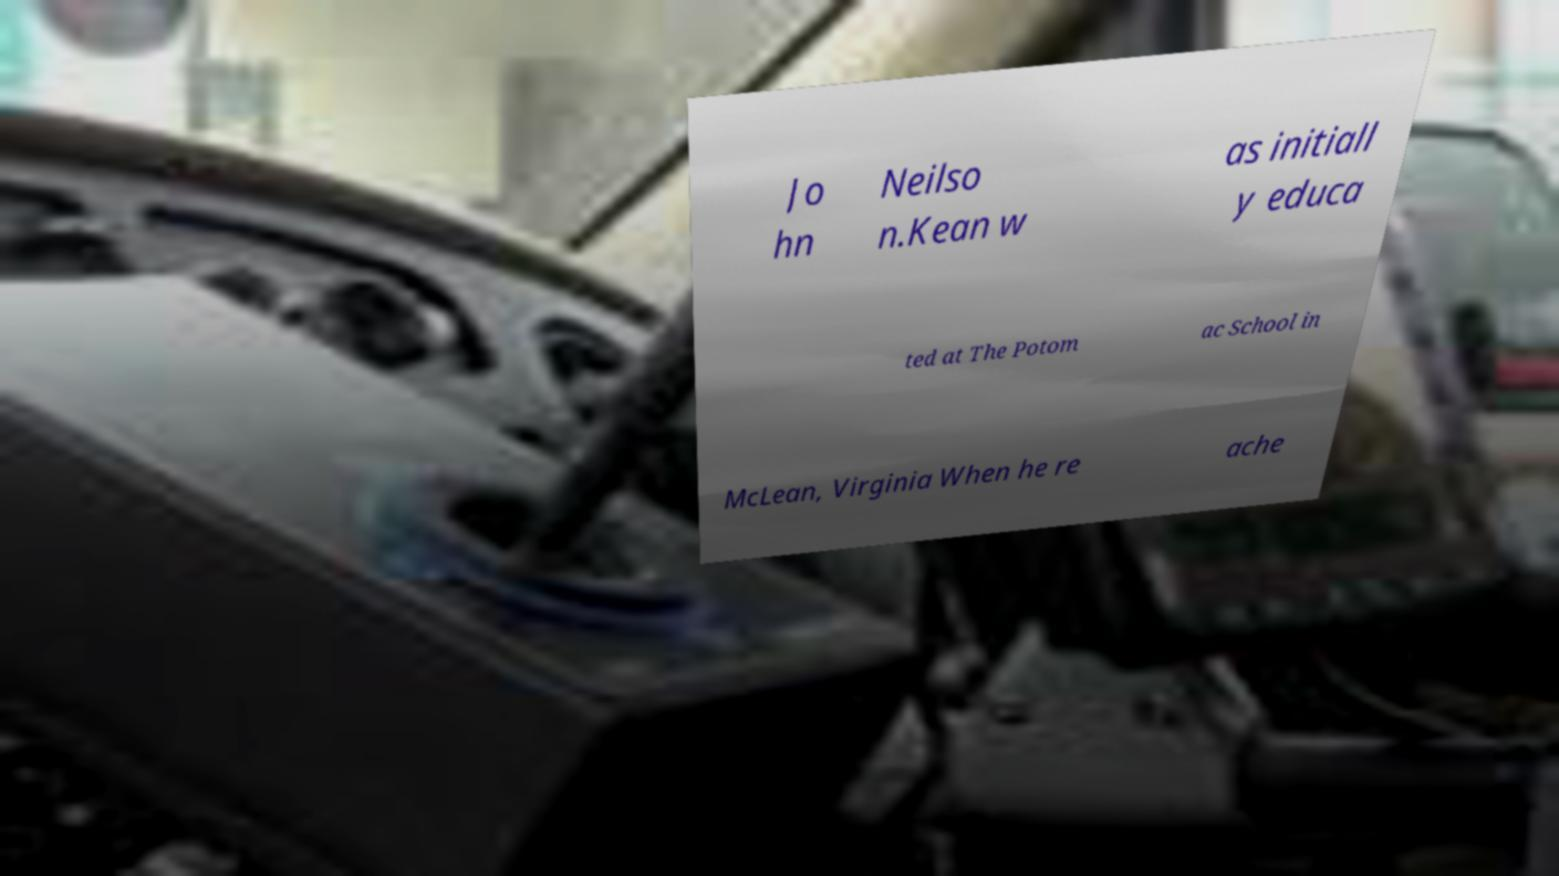Could you assist in decoding the text presented in this image and type it out clearly? Jo hn Neilso n.Kean w as initiall y educa ted at The Potom ac School in McLean, Virginia When he re ache 